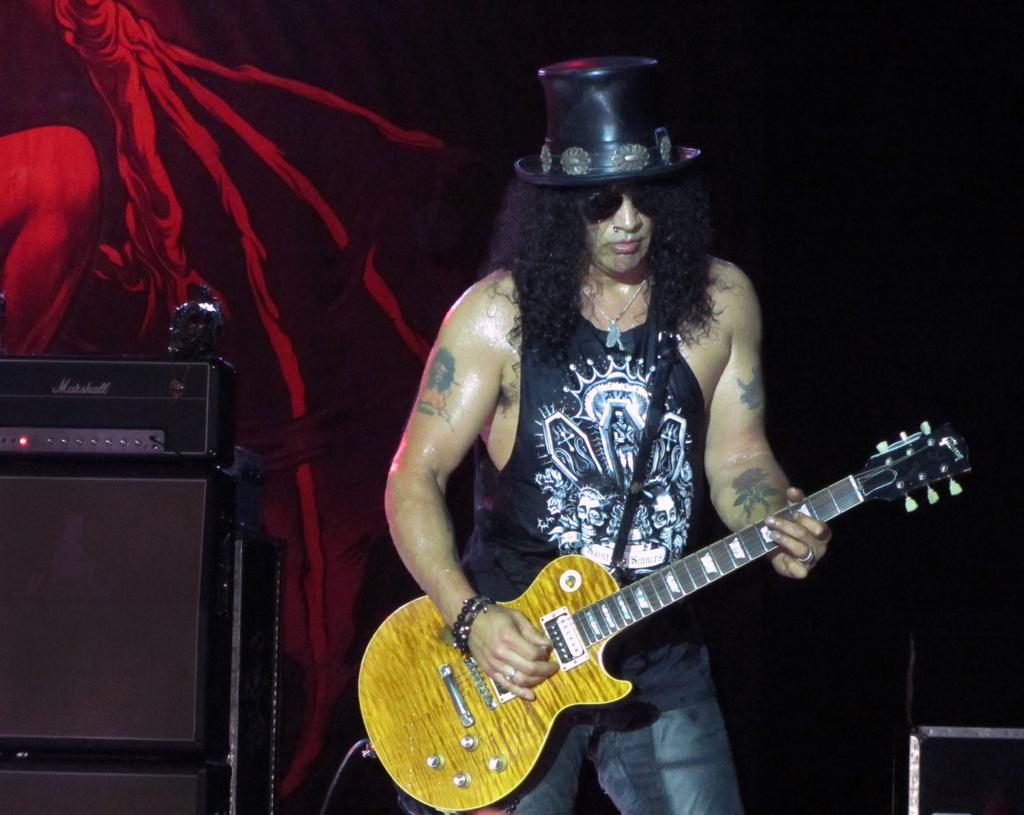What is the man in the image holding? The man is holding a guitar. Where is the man in the image? The man is on a stage. What is the man wearing on his upper body? The man is wearing a black t-shirt. What is the man wearing on his head? The man is wearing a hat. What is the man wearing on his face? The man is wearing spectacles. What can be seen in the background of the image? There is a wall in the background of the image. What is the appearance of the wall? The wall is painted. What color are the man's trousers in the image? The provided facts do not mention the color of the man's trousers, so we cannot determine their color from the image. How many feet can be seen in the image? The provided facts do not mention any feet in the image, so we cannot determine the number of feet visible. 